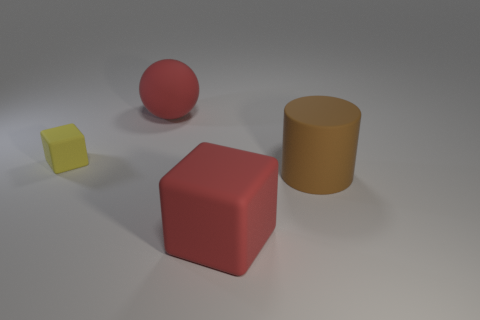What could be the possible uses for these objects in a real-world setting? In a real-world setting, these blocks might be utilized for various purposes. For instance, they could serve as educational tools for teaching children about shapes, colors, and spatial relationships. Alternatively, they could be part of a creative design or art installation, given their simplistic yet visually appealing forms. 